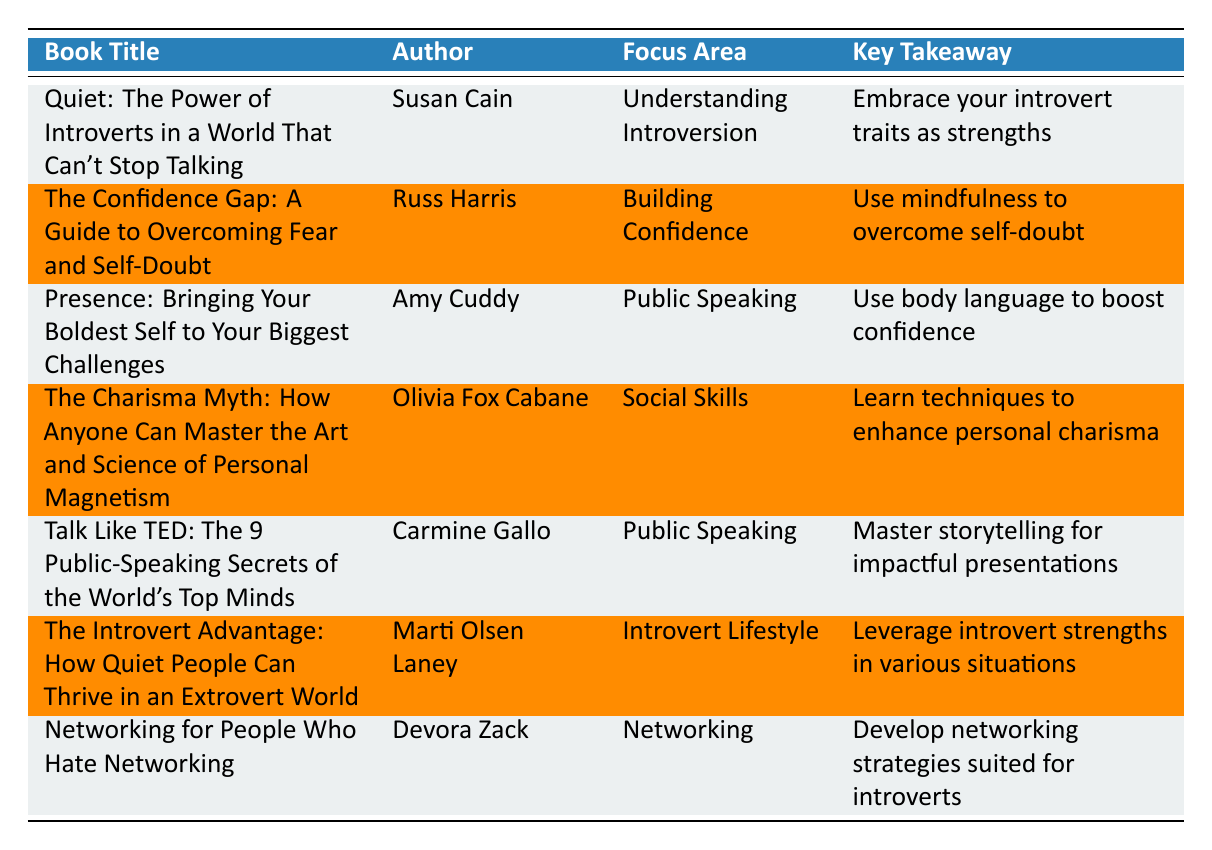What is the title of the book that focuses on understanding introversion? The table has a column for "Book Title" and another for "Focus Area." By scanning the "Focus Area" column, we see that "Understanding Introversion" corresponds to the book title "Quiet: The Power of Introverts in a World That Can't Stop Talking."
Answer: Quiet: The Power of Introverts in a World That Can't Stop Talking Who is the author of "The Confidence Gap"? The table provides the authors in the "Author" column aligned with their book titles. By looking for "The Confidence Gap" in the "Book Title" column, we find that Russ Harris is the associated author.
Answer: Russ Harris Does the table include a book focused on social skills? We can find out whether there's a book focused on social skills by checking the "Focus Area" column. The entry "Social Skills" indicates that there is indeed a book in the table that focuses on this topic.
Answer: Yes Which book provides techniques to enhance personal charisma? By looking through the "Key Takeaway" column, the entry for "Social Skills" points us to "The Charisma Myth: How Anyone Can Master the Art and Science of Personal Magnetism," which specifically mentions techniques for enhancing personal charisma.
Answer: The Charisma Myth: How Anyone Can Master the Art and Science of Personal Magnetism What is the average number of focus areas covered by the books listed? First, we count the number of unique focus areas in the "Focus Area" column: Understanding Introversion, Building Confidence, Public Speaking (2 books), Social Skills, Introvert Lifestyle, and Networking. This gives us a total of 6 distinct focus areas across 7 books. To find the average, we use the formula: Total number of unique focus areas / Total number of books = 6 / 7, which gives approximately 0.857.
Answer: Approximately 0.857 